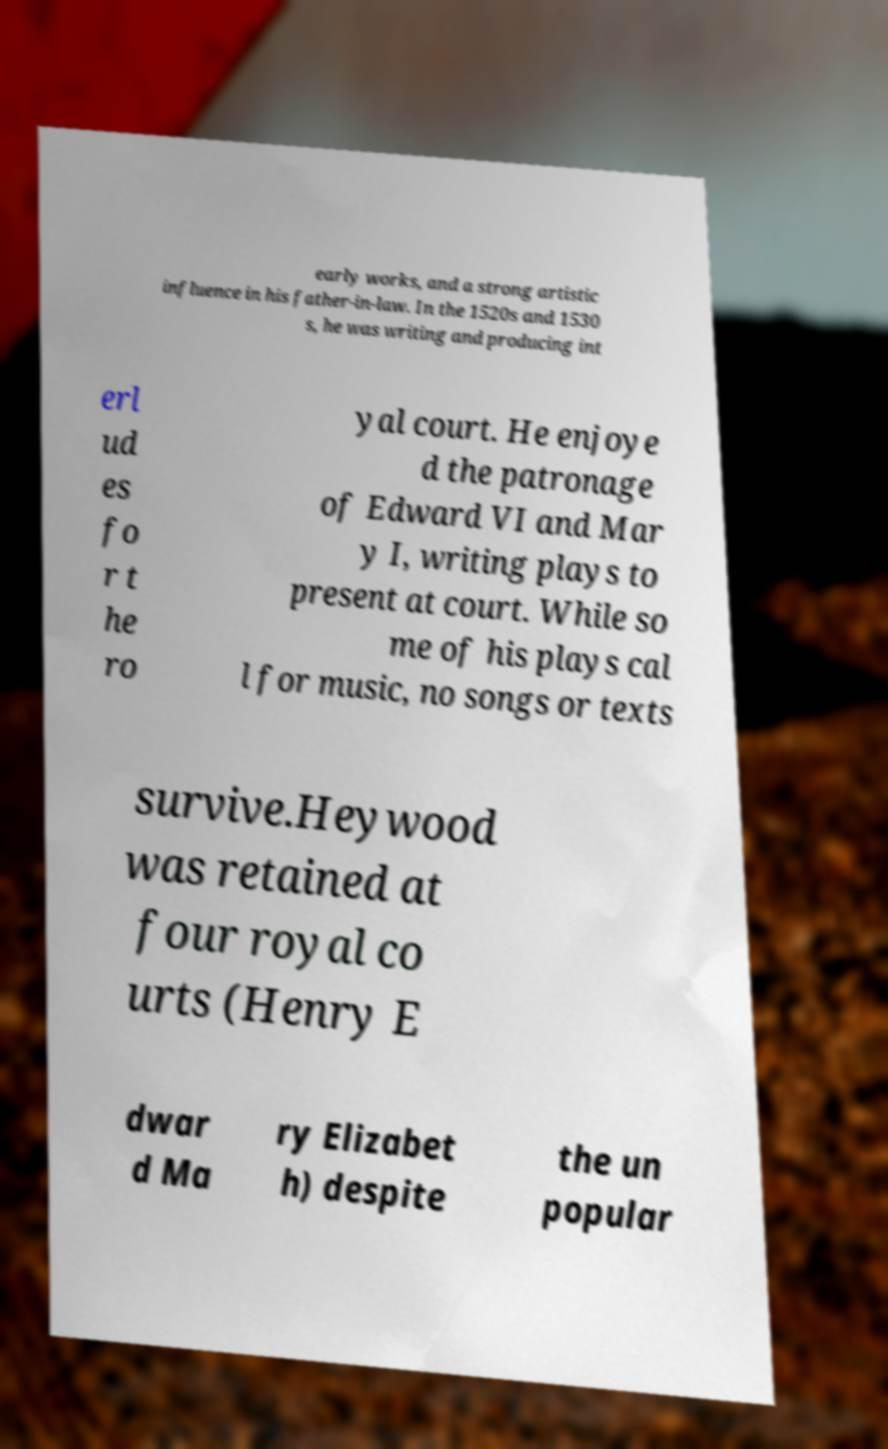For documentation purposes, I need the text within this image transcribed. Could you provide that? early works, and a strong artistic influence in his father-in-law. In the 1520s and 1530 s, he was writing and producing int erl ud es fo r t he ro yal court. He enjoye d the patronage of Edward VI and Mar y I, writing plays to present at court. While so me of his plays cal l for music, no songs or texts survive.Heywood was retained at four royal co urts (Henry E dwar d Ma ry Elizabet h) despite the un popular 